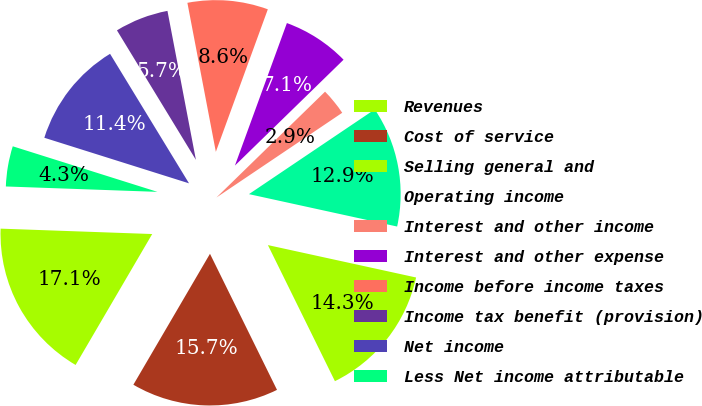Convert chart to OTSL. <chart><loc_0><loc_0><loc_500><loc_500><pie_chart><fcel>Revenues<fcel>Cost of service<fcel>Selling general and<fcel>Operating income<fcel>Interest and other income<fcel>Interest and other expense<fcel>Income before income taxes<fcel>Income tax benefit (provision)<fcel>Net income<fcel>Less Net income attributable<nl><fcel>17.14%<fcel>15.71%<fcel>14.29%<fcel>12.86%<fcel>2.86%<fcel>7.14%<fcel>8.57%<fcel>5.71%<fcel>11.43%<fcel>4.29%<nl></chart> 